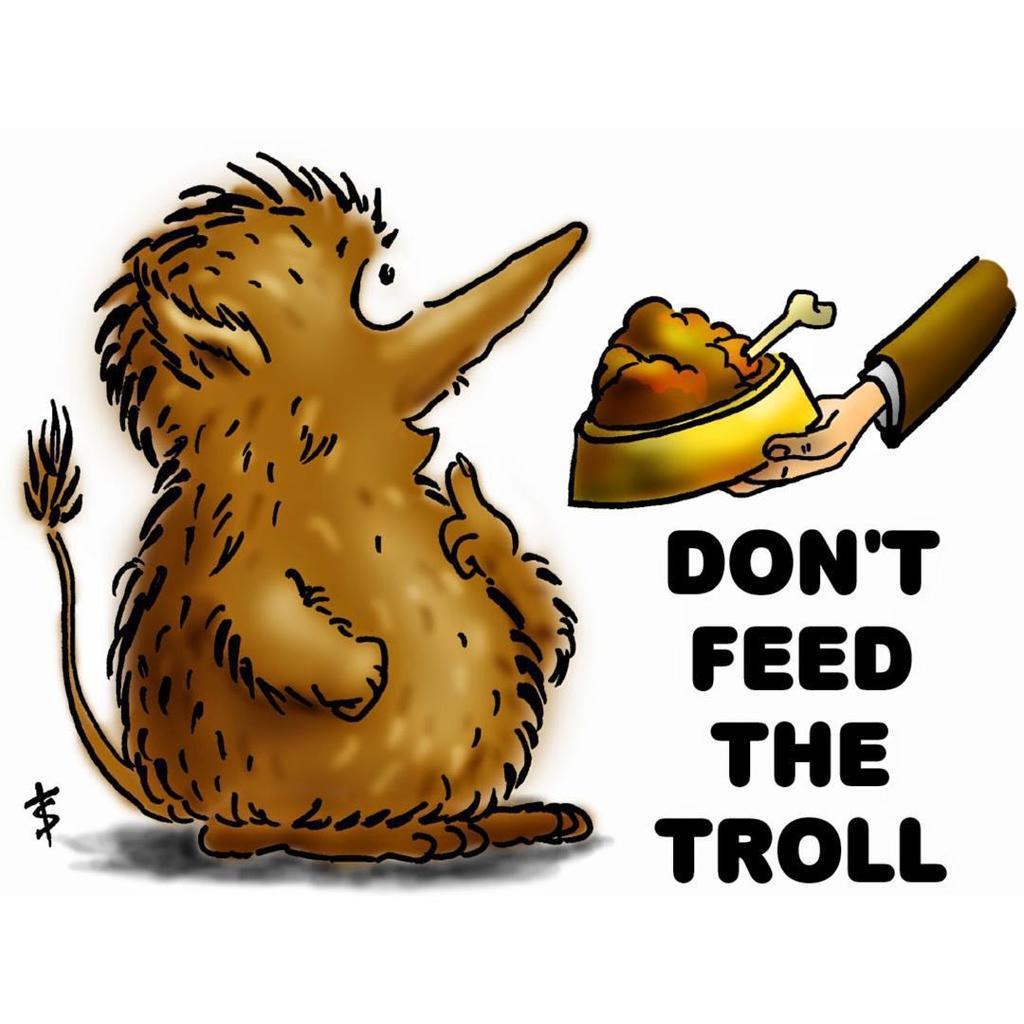How would you summarize this image in a sentence or two? In the picture we can see a cartoon image of a doll with tail and front of it, we can see a person's hand holding a food with bone in it and under the hand it is written as don't feed the troll. 